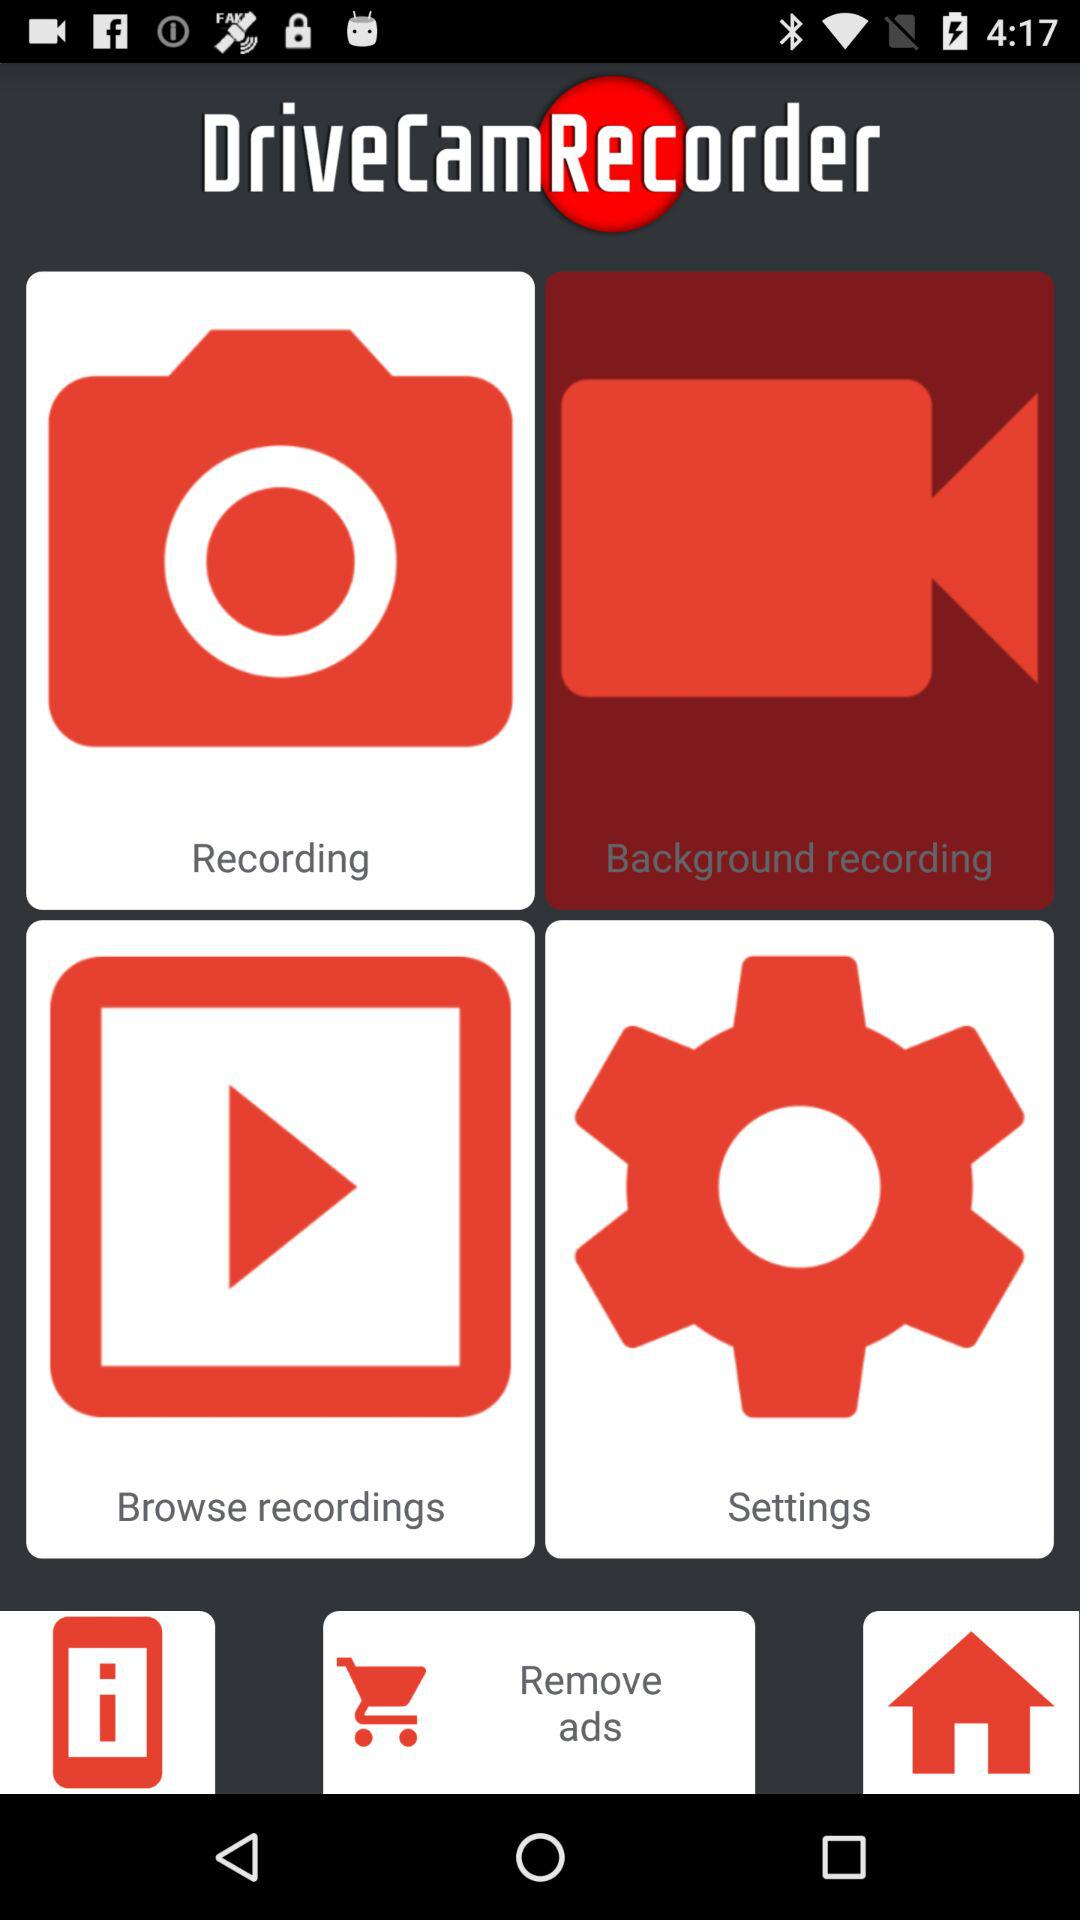What is the version? The version is v1.73. 